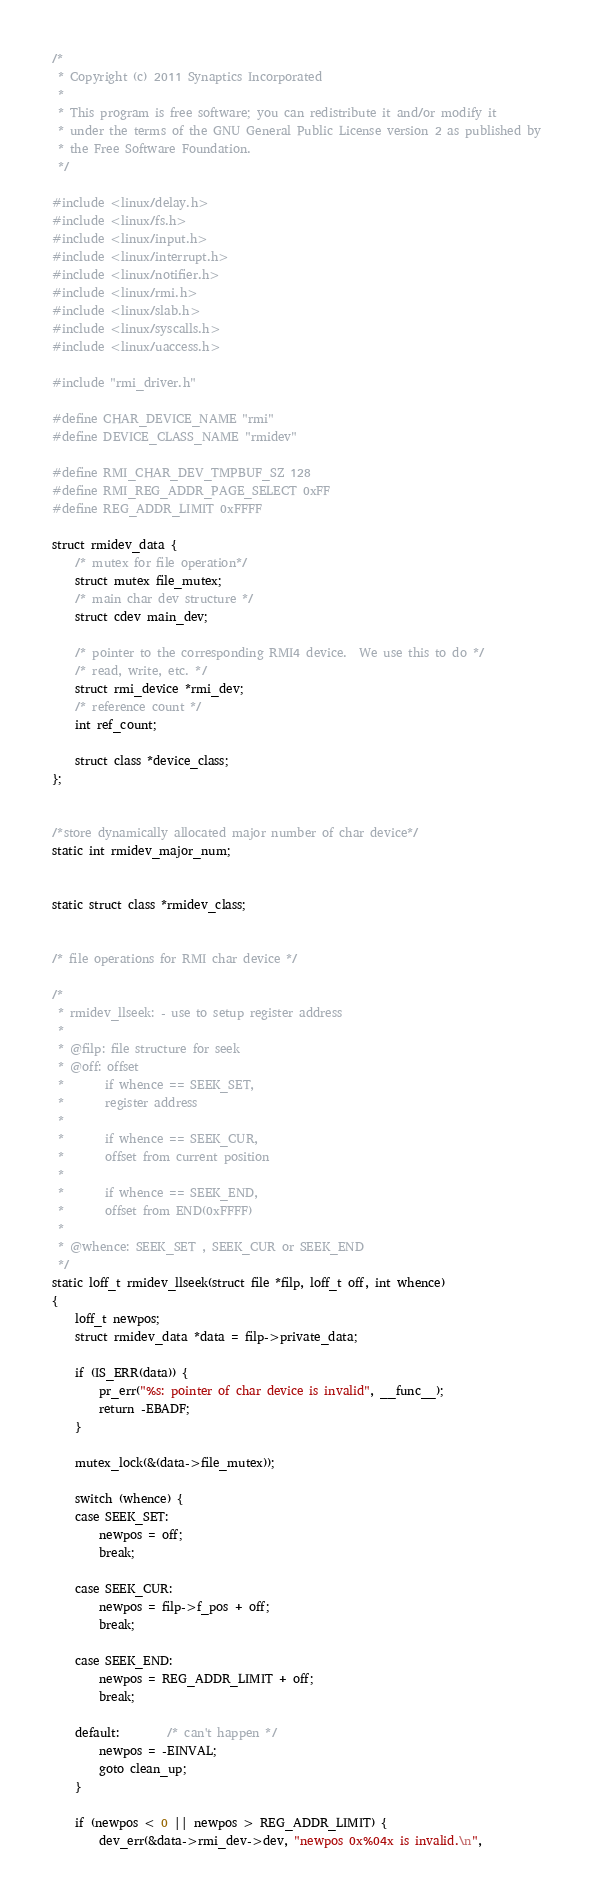Convert code to text. <code><loc_0><loc_0><loc_500><loc_500><_C_>/*
 * Copyright (c) 2011 Synaptics Incorporated
 *
 * This program is free software; you can redistribute it and/or modify it
 * under the terms of the GNU General Public License version 2 as published by
 * the Free Software Foundation.
 */

#include <linux/delay.h>
#include <linux/fs.h>
#include <linux/input.h>
#include <linux/interrupt.h>
#include <linux/notifier.h>
#include <linux/rmi.h>
#include <linux/slab.h>
#include <linux/syscalls.h>
#include <linux/uaccess.h>

#include "rmi_driver.h"

#define CHAR_DEVICE_NAME "rmi"
#define DEVICE_CLASS_NAME "rmidev"

#define RMI_CHAR_DEV_TMPBUF_SZ 128
#define RMI_REG_ADDR_PAGE_SELECT 0xFF
#define REG_ADDR_LIMIT 0xFFFF

struct rmidev_data {
	/* mutex for file operation*/
	struct mutex file_mutex;
	/* main char dev structure */
	struct cdev main_dev;

	/* pointer to the corresponding RMI4 device.  We use this to do */
	/* read, write, etc. */
	struct rmi_device *rmi_dev;
	/* reference count */
	int ref_count;

	struct class *device_class;
};


/*store dynamically allocated major number of char device*/
static int rmidev_major_num;


static struct class *rmidev_class;


/* file operations for RMI char device */

/*
 * rmidev_llseek: - use to setup register address
 *
 * @filp: file structure for seek
 * @off: offset
 *       if whence == SEEK_SET,
 *       register address
 *
 *       if whence == SEEK_CUR,
 *       offset from current position
 *
 *       if whence == SEEK_END,
 *       offset from END(0xFFFF)
 *
 * @whence: SEEK_SET , SEEK_CUR or SEEK_END
 */
static loff_t rmidev_llseek(struct file *filp, loff_t off, int whence)
{
	loff_t newpos;
	struct rmidev_data *data = filp->private_data;

	if (IS_ERR(data)) {
		pr_err("%s: pointer of char device is invalid", __func__);
		return -EBADF;
	}

	mutex_lock(&(data->file_mutex));

	switch (whence) {
	case SEEK_SET:
		newpos = off;
		break;

	case SEEK_CUR:
		newpos = filp->f_pos + off;
		break;

	case SEEK_END:
		newpos = REG_ADDR_LIMIT + off;
		break;

	default:		/* can't happen */
		newpos = -EINVAL;
		goto clean_up;
	}

	if (newpos < 0 || newpos > REG_ADDR_LIMIT) {
		dev_err(&data->rmi_dev->dev, "newpos 0x%04x is invalid.\n",</code> 